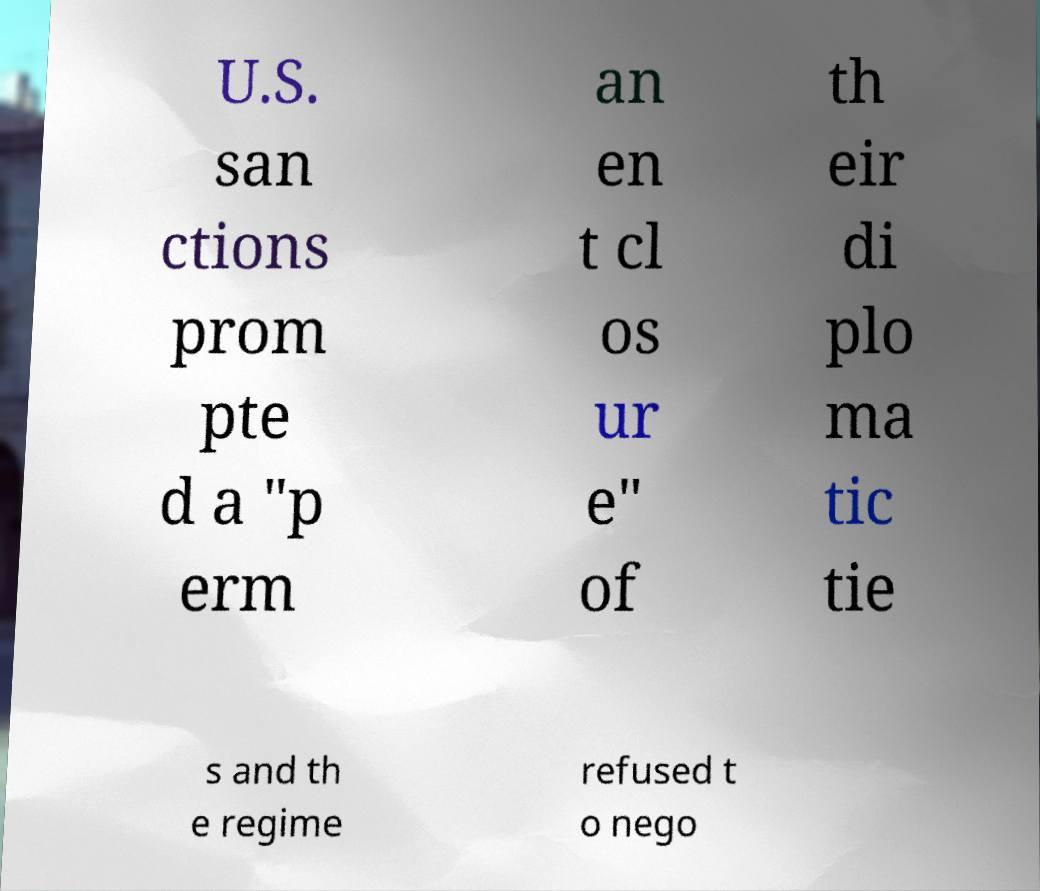There's text embedded in this image that I need extracted. Can you transcribe it verbatim? U.S. san ctions prom pte d a "p erm an en t cl os ur e" of th eir di plo ma tic tie s and th e regime refused t o nego 